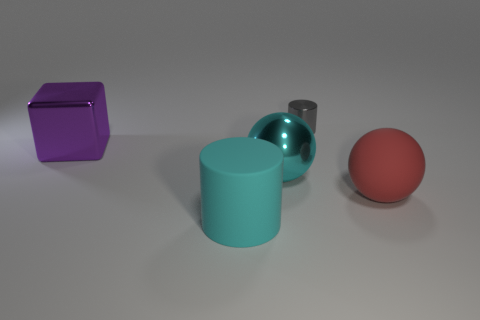Is there any other thing that has the same size as the shiny cylinder?
Your response must be concise. No. How many other things have the same shape as the red matte thing?
Your response must be concise. 1. There is a big metallic object that is on the right side of the metal cube; what color is it?
Offer a terse response. Cyan. How many rubber objects are either purple objects or tiny gray cylinders?
Give a very brief answer. 0. What shape is the large thing that is the same color as the metallic sphere?
Ensure brevity in your answer.  Cylinder. What number of purple things have the same size as the red matte ball?
Make the answer very short. 1. There is a object that is to the right of the cyan metallic thing and left of the matte sphere; what is its color?
Offer a terse response. Gray. How many objects are either big brown cylinders or big purple objects?
Give a very brief answer. 1. What number of tiny things are cubes or cyan objects?
Your answer should be compact. 0. Is there any other thing that is the same color as the small metal cylinder?
Your response must be concise. No. 